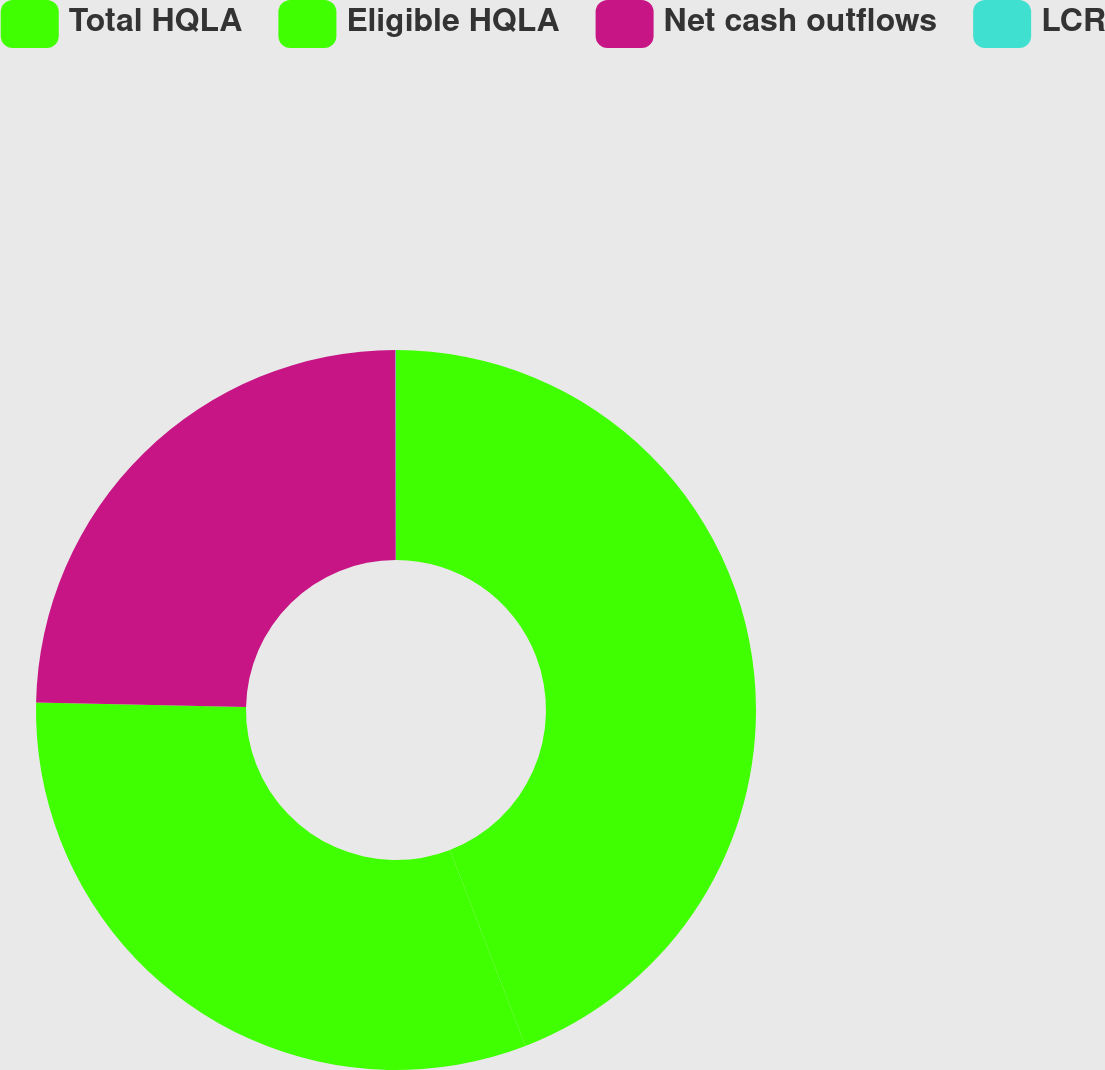Convert chart to OTSL. <chart><loc_0><loc_0><loc_500><loc_500><pie_chart><fcel>Total HQLA<fcel>Eligible HQLA<fcel>Net cash outflows<fcel>LCR<nl><fcel>44.14%<fcel>31.18%<fcel>24.65%<fcel>0.02%<nl></chart> 